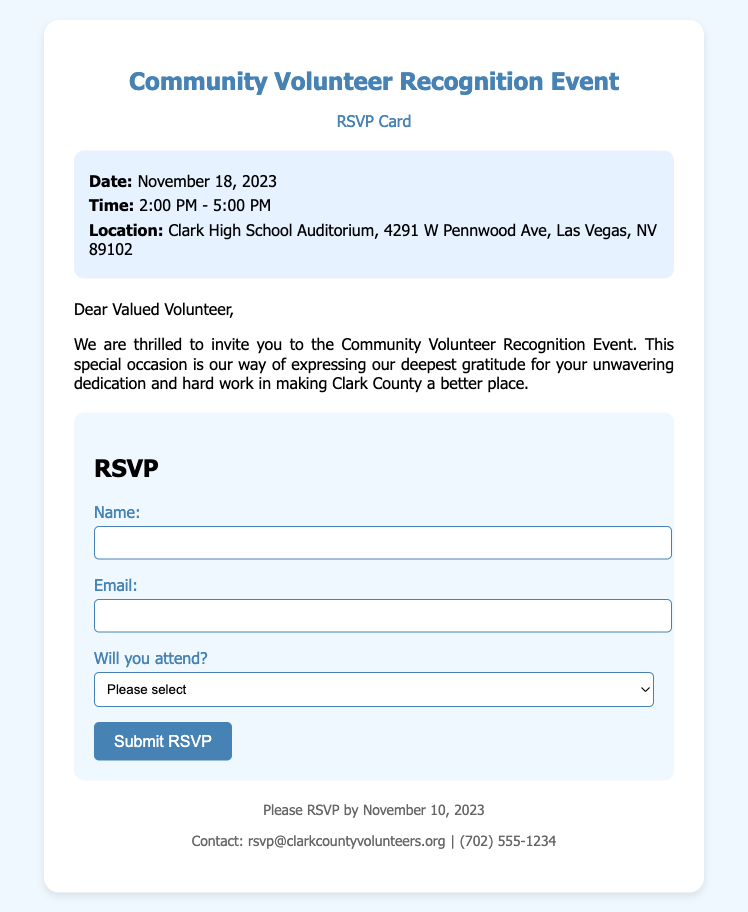What is the date of the event? The date of the event is mentioned in the event details section of the document.
Answer: November 18, 2023 What time does the event start? The start time is indicated in the event details section of the document.
Answer: 2:00 PM Where is the event located? The location of the event is provided in the event details section of the document.
Answer: Clark High School Auditorium, 4291 W Pennwood Ave, Las Vegas, NV 89102 What is the RSVP deadline? The RSVP deadline is specified in the footer of the document.
Answer: November 10, 2023 What is the contact email for the event? The contact information is available in the footer of the document.
Answer: rsvp@clarkcountyvolunteers.org Will there be individual acknowledgment for volunteers? The opening message implies that there will be personal recognition at the event, emphasizing gratitude for volunteers.
Answer: Yes What is the purpose of the event? The purpose is stated in the message section, reflecting the intention behind the gathering.
Answer: To express gratitude How can attendees confirm their attendance? The RSVP section indicates the way to confirm attendance through the form.
Answer: By submitting the RSVP form 